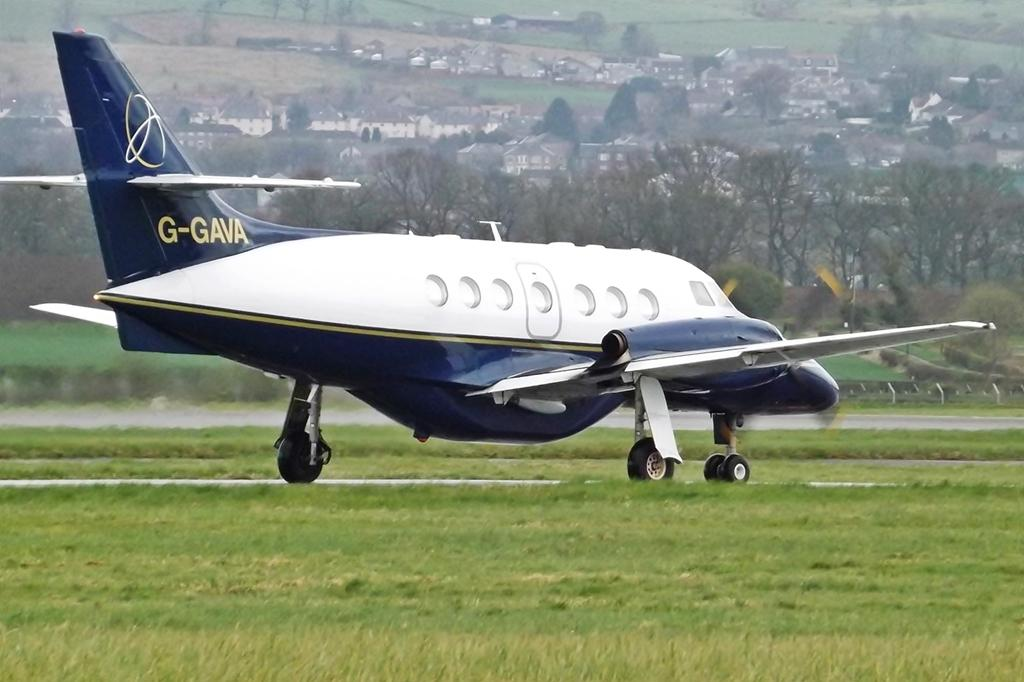<image>
Offer a succinct explanation of the picture presented. A white and blue airplane is marked G-GAVA on the tail. 